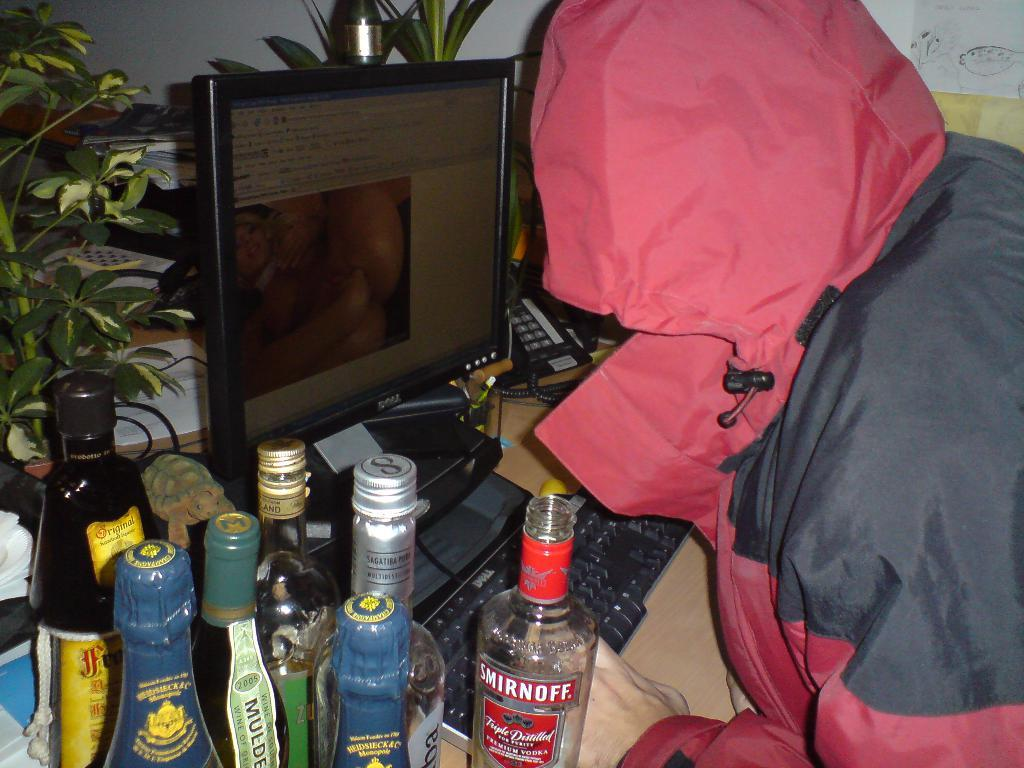What electronic device is visible in the image? There is a monitor in the image. What is the person using along with the monitor? There is a keyboard in the image, which the person is using along with the monitor. What type of objects are present in large quantities in the image? There are a lot of bottles in the image. What is the person in the image doing? The person is looking at the monitor and keyboard. What type of meal is being prepared on the linen in the image? There is no meal or linen present in the image; it only features a monitor, keyboard, and bottles. 